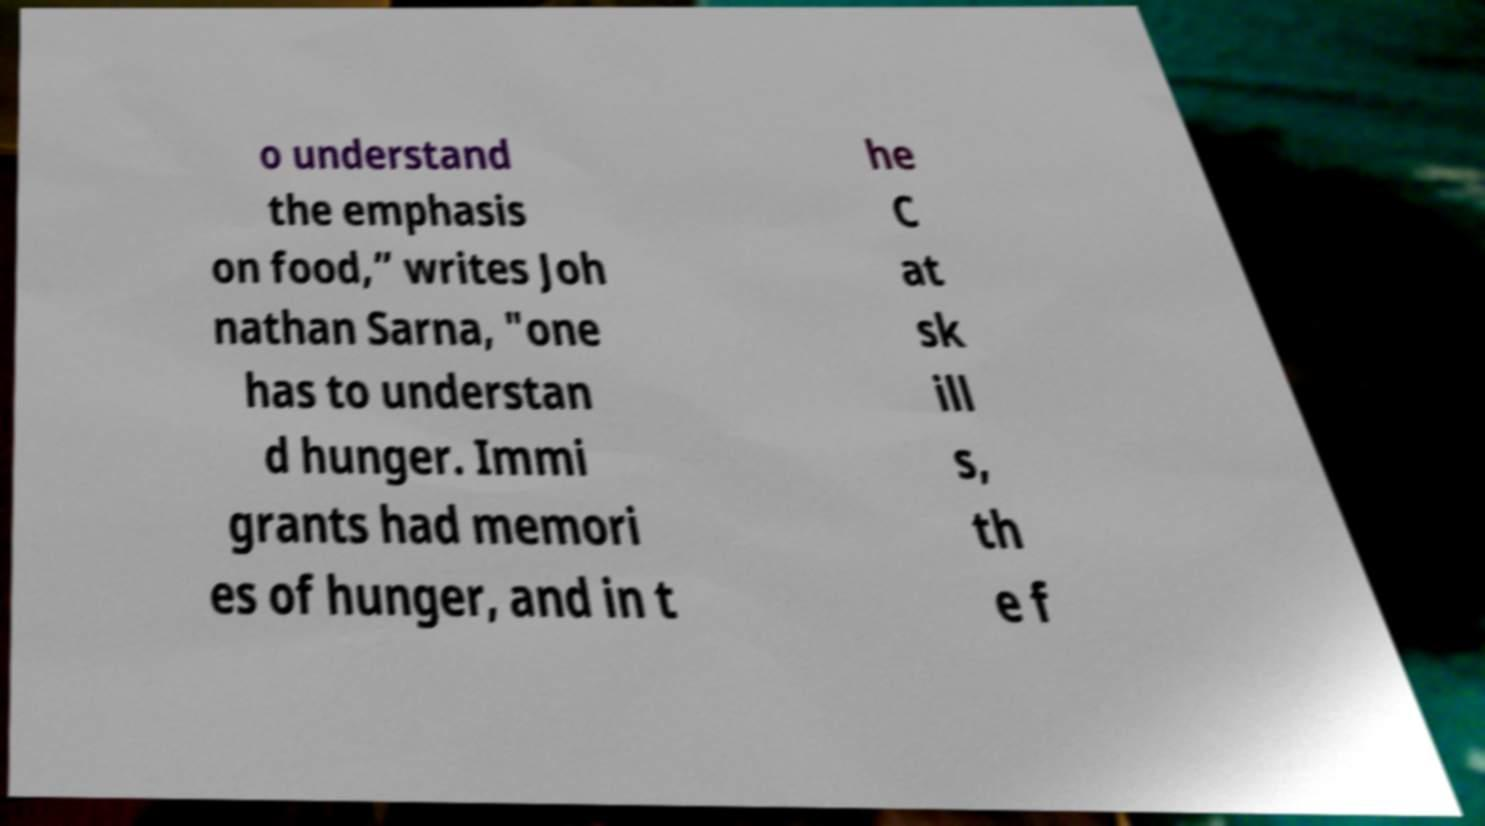Please read and relay the text visible in this image. What does it say? o understand the emphasis on food,” writes Joh nathan Sarna, "one has to understan d hunger. Immi grants had memori es of hunger, and in t he C at sk ill s, th e f 